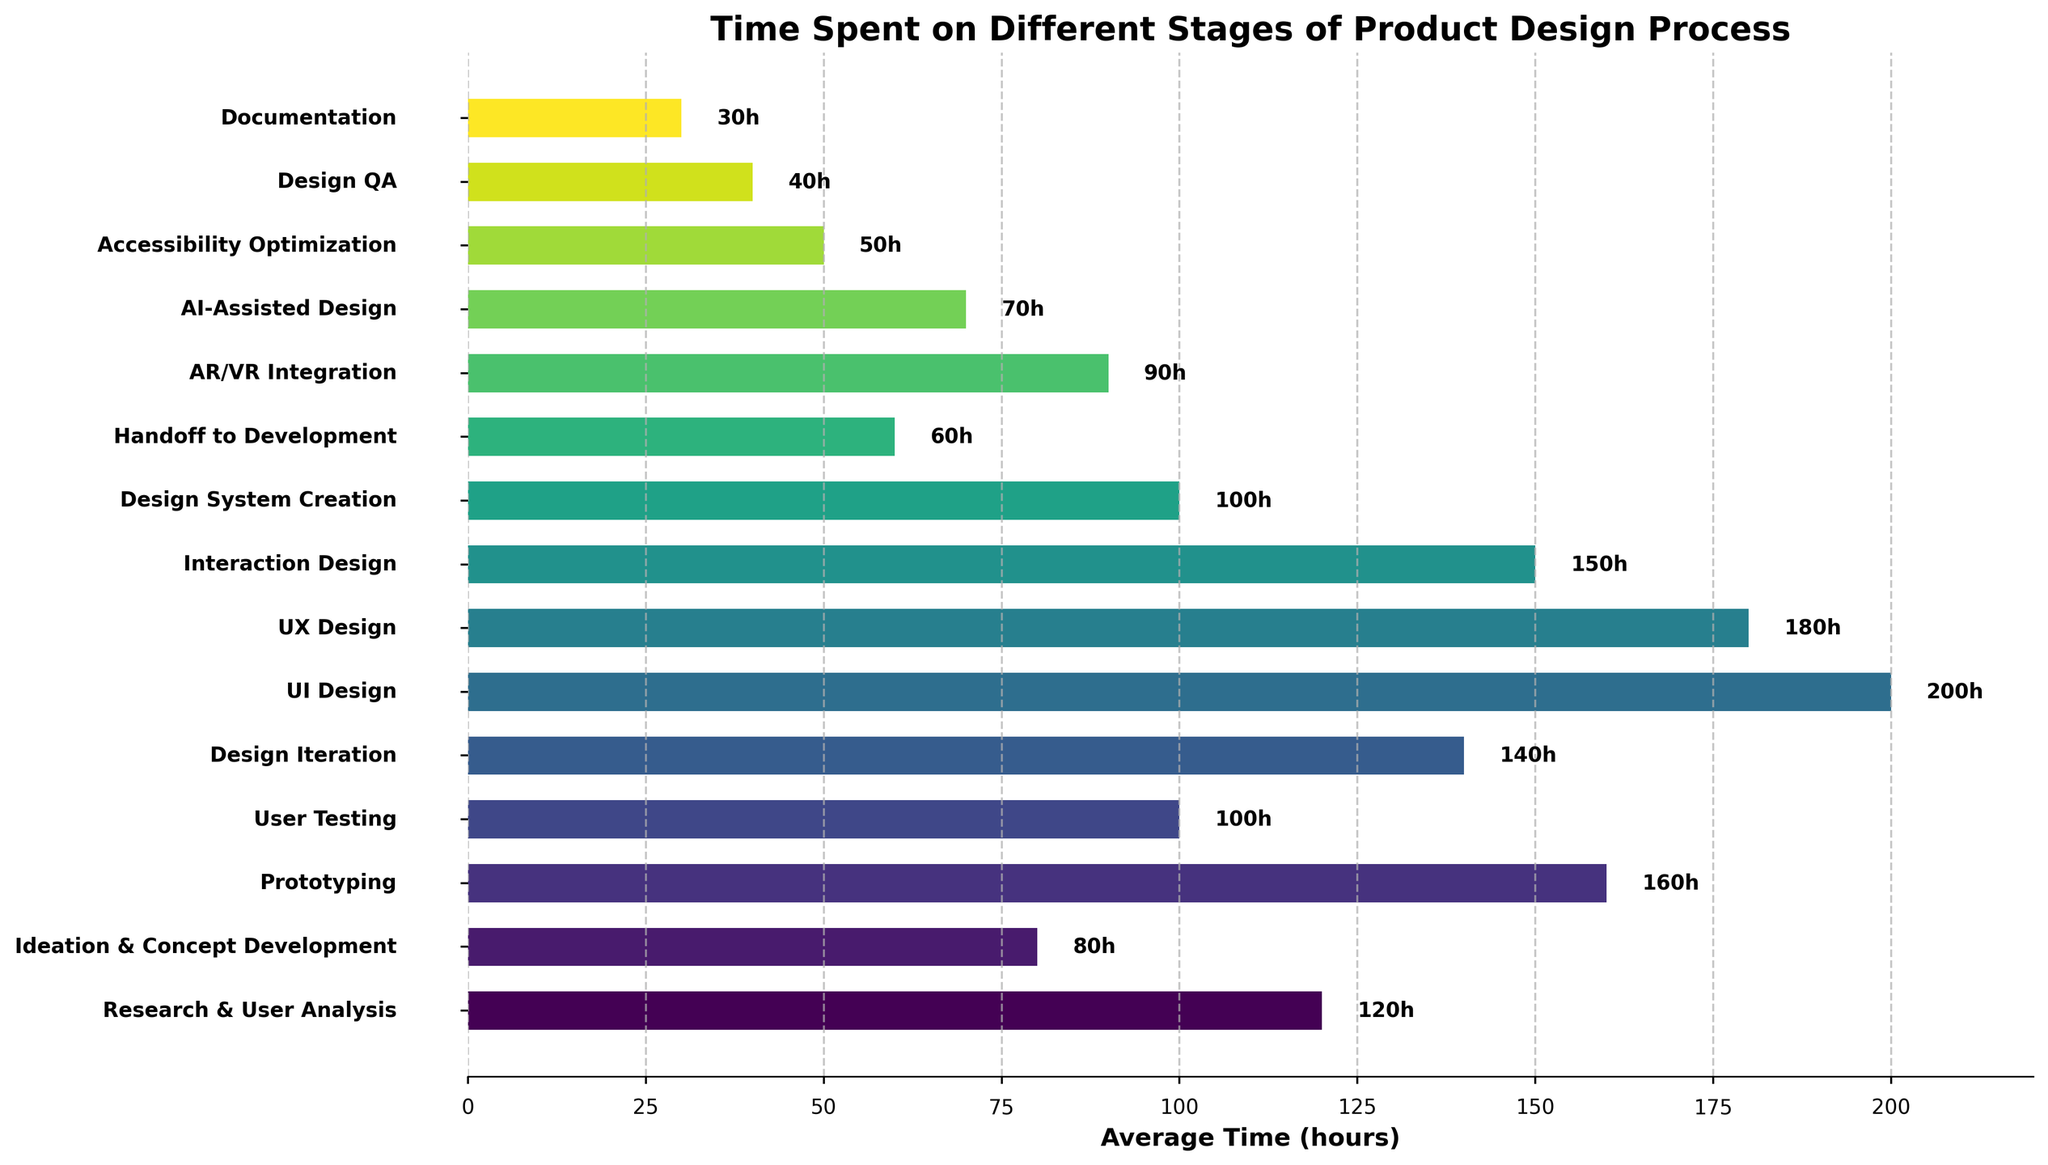Which stage requires the most time in the product design process? Look at the horizontal bars and identify the one that reaches the farthest on the right side. The stage corresponding to this bar is 'UI Design'.
Answer: UI Design What is the total time spent on Ideation & Concept Development and User Testing? Check the horizontal bars for 'Ideation & Concept Development' and 'User Testing'. Add their lengths together, which correspond to 80 and 100 hours respectively. Thus, 80 + 100 = 180 hours.
Answer: 180 hours Are more hours spent on Interaction Design or on AR/VR Integration? Compare the lengths of the horizontal bars for 'Interaction Design' and 'AR/VR Integration'. 'Interaction Design' has 150 hours, and 'AR/VR Integration' has 90 hours.
Answer: Interaction Design Which stage takes the least amount of time? Look for the shortest horizontal bar on the chart. The shortest bar corresponds to 'Documentation'.
Answer: Documentation Which stages require exactly 100 hours? Identify the bars that reach 100 on the x-axis. These stages are 'User Testing' and 'Design System Creation'.
Answer: User Testing, Design System Creation How much more time is spent on UX Design than on Accessibility Optimization? Locate and note the lengths of the horizontal bars for UX Design and Accessibility Optimization. UX Design takes 180 hours and Accessibility Optimization takes 50 hours. Subtract 50 from 180, which gives 180 - 50 = 130 hours.
Answer: 130 hours What's the combined time spent on Prototyping, Design Iteration, and AI-Assisted Design? Add up the hours for Prototyping, Design Iteration, and AI-Assisted Design. These are 160, 140, and 70 respectively. Therefore, 160 + 140 + 70 = 370 hours.
Answer: 370 hours 